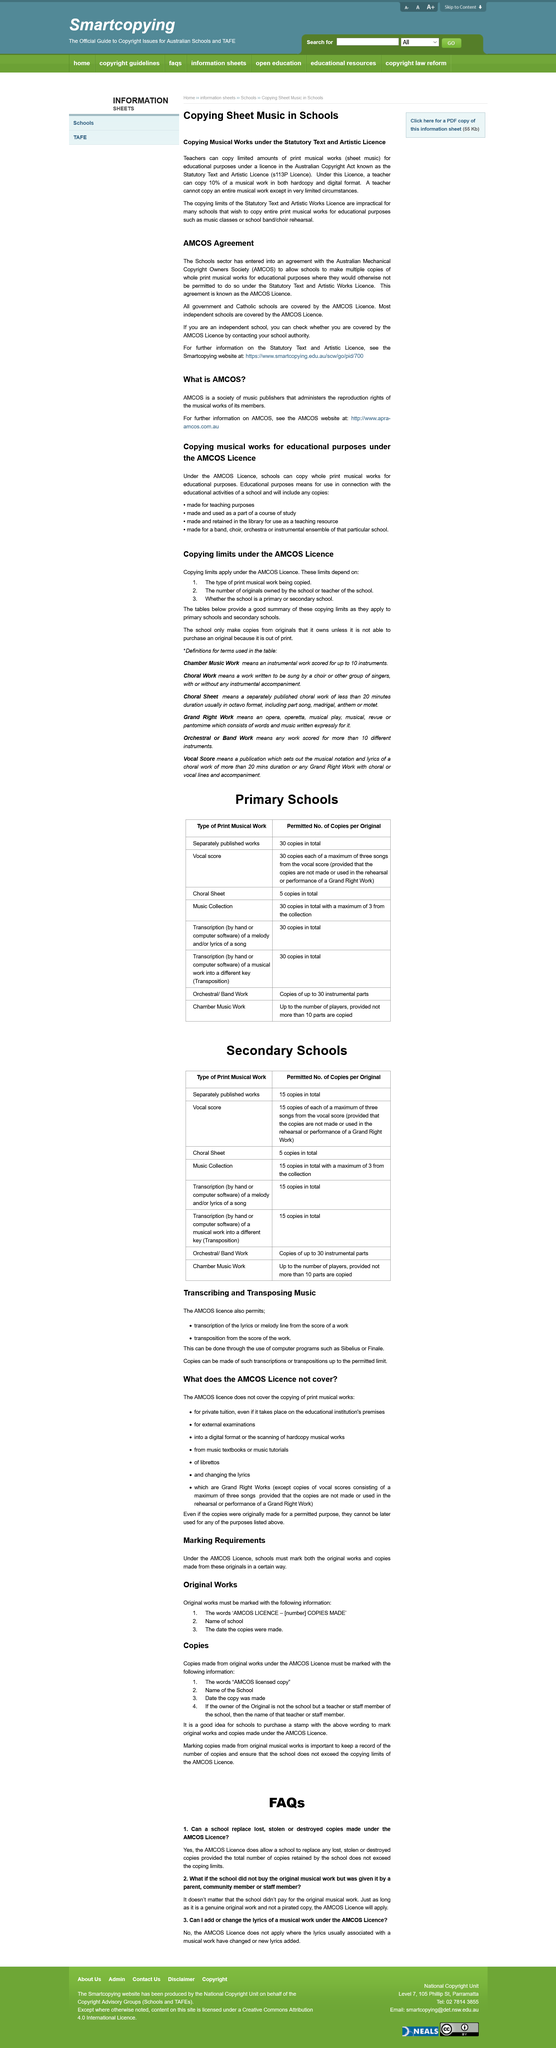Point out several critical features in this image. The library is authorized to create and retain copies of musical works for the purpose of using them as a teaching resource. It is not permissible to add or modify lyrics under the AMCOS license. The AMCOS licence applies copying limits to secondary schools. AMCOS is a society of music publishers that administers the reproduction rights of the musical works of its members, as declared. Copying musical works is allowed under this license for educational purposes, but only up to 10% of a musical work can be copied in both hard copy and digital form, and this is limited to specific educational purposes only. 